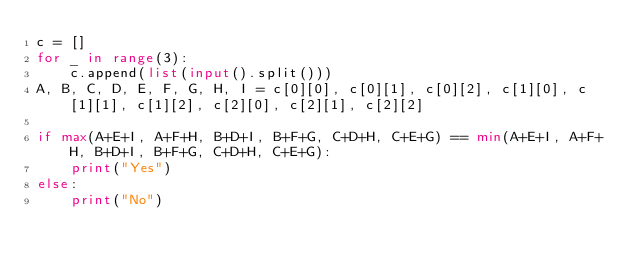Convert code to text. <code><loc_0><loc_0><loc_500><loc_500><_Python_>c = []
for _ in range(3):
    c.append(list(input().split()))
A, B, C, D, E, F, G, H, I = c[0][0], c[0][1], c[0][2], c[1][0], c[1][1], c[1][2], c[2][0], c[2][1], c[2][2]

if max(A+E+I, A+F+H, B+D+I, B+F+G, C+D+H, C+E+G) == min(A+E+I, A+F+H, B+D+I, B+F+G, C+D+H, C+E+G):
    print("Yes")
else:
    print("No")
</code> 